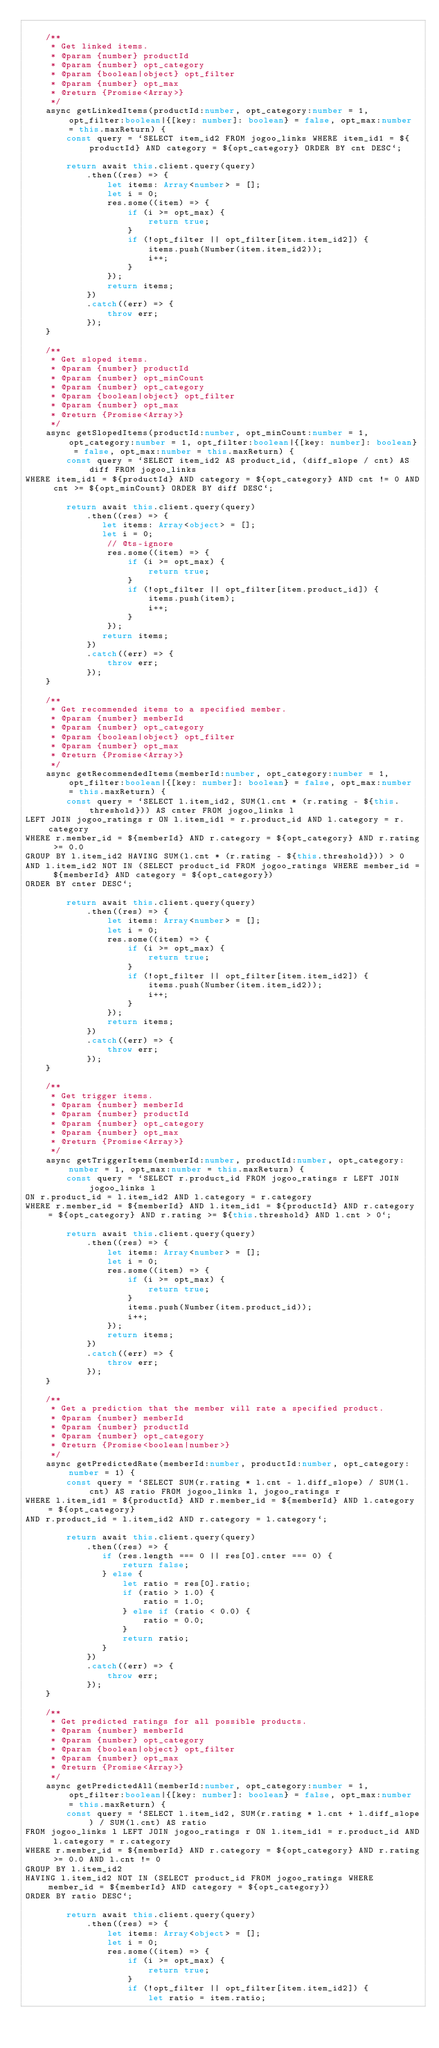<code> <loc_0><loc_0><loc_500><loc_500><_TypeScript_>
    /**
     * Get linked items.
     * @param {number} productId
     * @param {number} opt_category
     * @param {boolean|object} opt_filter
     * @param {number} opt_max
     * @return {Promise<Array>}
     */
    async getLinkedItems(productId:number, opt_category:number = 1, opt_filter:boolean|{[key: number]: boolean} = false, opt_max:number = this.maxReturn) {
        const query = `SELECT item_id2 FROM jogoo_links WHERE item_id1 = ${productId} AND category = ${opt_category} ORDER BY cnt DESC`;

        return await this.client.query(query)
            .then((res) => {
                let items: Array<number> = [];
                let i = 0;
                res.some((item) => {
                    if (i >= opt_max) {
                        return true;
                    }
                    if (!opt_filter || opt_filter[item.item_id2]) {
                        items.push(Number(item.item_id2));
                        i++;
                    }
                });
                return items;
            })
            .catch((err) => {
                throw err;
            });
    }

    /**
     * Get sloped items.
     * @param {number} productId
     * @param {number} opt_minCount
     * @param {number} opt_category
     * @param {boolean|object} opt_filter
     * @param {number} opt_max
     * @return {Promise<Array>}
     */
    async getSlopedItems(productId:number, opt_minCount:number = 1, opt_category:number = 1, opt_filter:boolean|{[key: number]: boolean} = false, opt_max:number = this.maxReturn) {
        const query = `SELECT item_id2 AS product_id, (diff_slope / cnt) AS diff FROM jogoo_links
WHERE item_id1 = ${productId} AND category = ${opt_category} AND cnt != 0 AND cnt >= ${opt_minCount} ORDER BY diff DESC`;

        return await this.client.query(query)
            .then((res) => {
               let items: Array<object> = [];
               let i = 0;
                // @ts-ignore
                res.some((item) => {
                    if (i >= opt_max) {
                        return true;
                    }
                    if (!opt_filter || opt_filter[item.product_id]) {
                        items.push(item);
                        i++;
                    }
                });
               return items;
            })
            .catch((err) => {
                throw err;
            });
    }

    /**
     * Get recommended items to a specified member.
     * @param {number} memberId
     * @param {number} opt_category
     * @param {boolean|object} opt_filter
     * @param {number} opt_max
     * @return {Promise<Array>}
     */
    async getRecommendedItems(memberId:number, opt_category:number = 1, opt_filter:boolean|{[key: number]: boolean} = false, opt_max:number = this.maxReturn) {
        const query = `SELECT l.item_id2, SUM(l.cnt * (r.rating - ${this.threshold})) AS cnter FROM jogoo_links l
LEFT JOIN jogoo_ratings r ON l.item_id1 = r.product_id AND l.category = r.category
WHERE r.member_id = ${memberId} AND r.category = ${opt_category} AND r.rating >= 0.0
GROUP BY l.item_id2 HAVING SUM(l.cnt * (r.rating - ${this.threshold})) > 0
AND l.item_id2 NOT IN (SELECT product_id FROM jogoo_ratings WHERE member_id = ${memberId} AND category = ${opt_category})
ORDER BY cnter DESC`;

        return await this.client.query(query)
            .then((res) => {
                let items: Array<number> = [];
                let i = 0;
                res.some((item) => {
                    if (i >= opt_max) {
                        return true;
                    }
                    if (!opt_filter || opt_filter[item.item_id2]) {
                        items.push(Number(item.item_id2));
                        i++;
                    }
                });
                return items;
            })
            .catch((err) => {
                throw err;
            });
    }

    /**
     * Get trigger items.
     * @param {number} memberId
     * @param {number} productId
     * @param {number} opt_category
     * @param {number} opt_max
     * @return {Promise<Array>}
     */
    async getTriggerItems(memberId:number, productId:number, opt_category:number = 1, opt_max:number = this.maxReturn) {
        const query = `SELECT r.product_id FROM jogoo_ratings r LEFT JOIN jogoo_links l
ON r.product_id = l.item_id2 AND l.category = r.category
WHERE r.member_id = ${memberId} AND l.item_id1 = ${productId} AND r.category = ${opt_category} AND r.rating >= ${this.threshold} AND l.cnt > 0`;

        return await this.client.query(query)
            .then((res) => {
                let items: Array<number> = [];
                let i = 0;
                res.some((item) => {
                    if (i >= opt_max) {
                        return true;
                    }
                    items.push(Number(item.product_id));
                    i++;
                });
                return items;
            })
            .catch((err) => {
                throw err;
            });
    }

    /**
     * Get a prediction that the member will rate a specified product.
     * @param {number} memberId
     * @param {number} productId
     * @param {number} opt_category
     * @return {Promise<boolean|number>}
     */
    async getPredictedRate(memberId:number, productId:number, opt_category:number = 1) {
        const query = `SELECT SUM(r.rating * l.cnt - l.diff_slope) / SUM(l.cnt) AS ratio FROM jogoo_links l, jogoo_ratings r
WHERE l.item_id1 = ${productId} AND r.member_id = ${memberId} AND l.category = ${opt_category}
AND r.product_id = l.item_id2 AND r.category = l.category`;

        return await this.client.query(query)
            .then((res) => {
               if (res.length === 0 || res[0].cnter === 0) {
                   return false;
               } else {
                   let ratio = res[0].ratio;
                   if (ratio > 1.0) {
                       ratio = 1.0;
                   } else if (ratio < 0.0) {
                       ratio = 0.0;
                   }
                   return ratio;
               }
            })
            .catch((err) => {
                throw err;
            });
    }

    /**
     * Get predicted ratings for all possible products.
     * @param {number} memberId
     * @param {number} opt_category
     * @param {boolean|object} opt_filter
     * @param {number} opt_max
     * @return {Promise<Array>}
     */
    async getPredictedAll(memberId:number, opt_category:number = 1, opt_filter:boolean|{[key: number]: boolean} = false, opt_max:number = this.maxReturn) {
        const query = `SELECT l.item_id2, SUM(r.rating * l.cnt + l.diff_slope) / SUM(l.cnt) AS ratio
FROM jogoo_links l LEFT JOIN jogoo_ratings r ON l.item_id1 = r.product_id AND l.category = r.category
WHERE r.member_id = ${memberId} AND r.category = ${opt_category} AND r.rating >= 0.0 AND l.cnt != 0
GROUP BY l.item_id2
HAVING l.item_id2 NOT IN (SELECT product_id FROM jogoo_ratings WHERE member_id = ${memberId} AND category = ${opt_category})
ORDER BY ratio DESC`;

        return await this.client.query(query)
            .then((res) => {
                let items: Array<object> = [];
                let i = 0;
                res.some((item) => {
                    if (i >= opt_max) {
                        return true;
                    }
                    if (!opt_filter || opt_filter[item.item_id2]) {
                        let ratio = item.ratio;</code> 